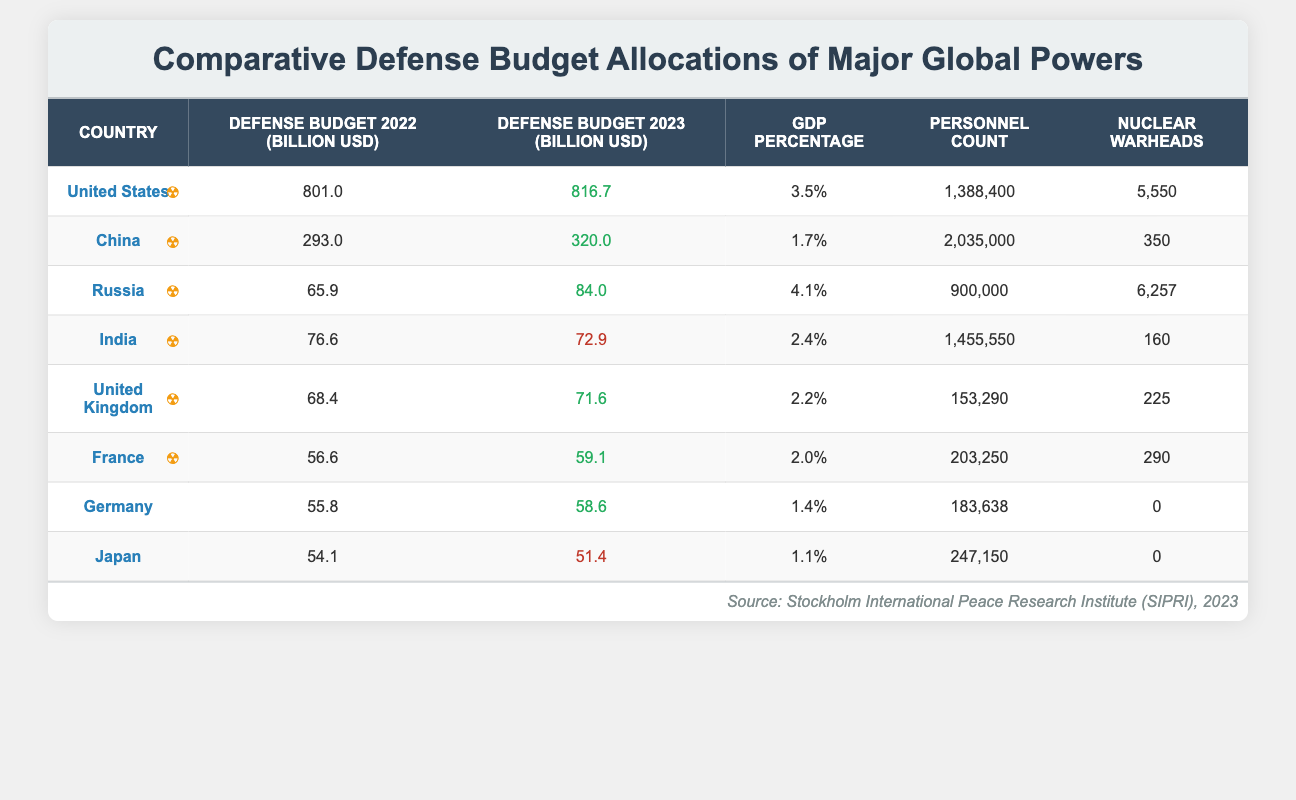What is the defense budget of China for 2023? The table lists the defense budget for each country for 2023. For China, the value provided is 320.0 billion USD.
Answer: 320.0 billion USD Which country has the highest defense budget for 2022? By comparing the defense budgets for 2022, the United States has the highest value at 801.0 billion USD.
Answer: United States How much did India's defense budget decrease from 2022 to 2023? The defense budget for India in 2022 is 76.6 billion USD and in 2023 is 72.9 billion USD. The decrease is calculated as 76.6 - 72.9 = 3.7 billion USD.
Answer: 3.7 billion USD Is the percentage of GDP allocated to defense in Russia higher than in the United Kingdom? Russia's GDP percentage for defense is 4.1% while the UK's is 2.2%. Since 4.1% is greater than 2.2%, the statement is true.
Answer: Yes What is the combined defense budget of the United States and China for 2023? Adding the defense budgets for 2023, the United States is 816.7 billion USD and China is 320.0 billion USD. The total is 816.7 + 320.0 = 1136.7 billion USD.
Answer: 1136.7 billion USD Which country has the smallest personnel count? Examining the personnel counts, the United Kingdom has the smallest figure with 153,290 personnel.
Answer: United Kingdom How much larger is the defense budget of the United States compared to India in 2023? In 2023, the United States has a budget of 816.7 billion USD and India has 72.9 billion USD. The difference is 816.7 - 72.9 = 743.8 billion USD.
Answer: 743.8 billion USD Are there any countries in the table without nuclear warheads? Checking the nuclear warheads column, both Germany and Japan have 0 nuclear warheads, so the answer is yes.
Answer: Yes What is the average defense budget of the countries listed for 2023? The sum of the defense budgets for 2023 is 816.7 + 320.0 + 84.0 + 72.9 + 71.6 + 59.1 + 58.6 + 51.4 = 1,475.3 billion USD. There are 8 countries, so the average is 1,475.3 / 8 = 184.44 billion USD.
Answer: 184.44 billion USD 